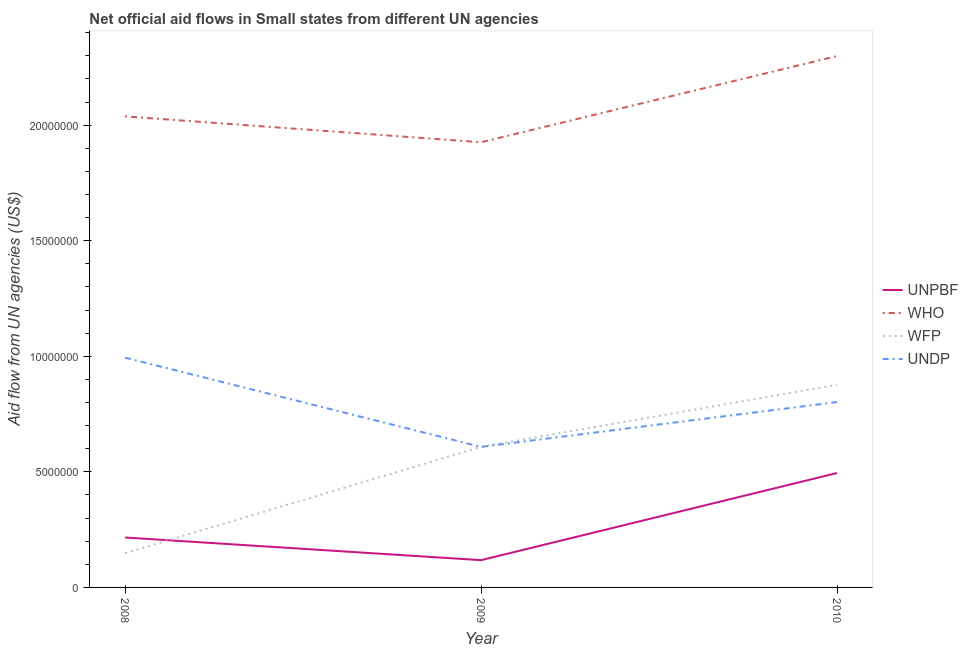Is the number of lines equal to the number of legend labels?
Your response must be concise. Yes. What is the amount of aid given by undp in 2009?
Make the answer very short. 6.08e+06. Across all years, what is the maximum amount of aid given by who?
Keep it short and to the point. 2.30e+07. Across all years, what is the minimum amount of aid given by wfp?
Provide a short and direct response. 1.48e+06. In which year was the amount of aid given by unpbf minimum?
Offer a very short reply. 2009. What is the total amount of aid given by unpbf in the graph?
Ensure brevity in your answer.  8.29e+06. What is the difference between the amount of aid given by wfp in 2009 and that in 2010?
Ensure brevity in your answer.  -2.69e+06. What is the difference between the amount of aid given by who in 2009 and the amount of aid given by undp in 2010?
Ensure brevity in your answer.  1.12e+07. What is the average amount of aid given by undp per year?
Ensure brevity in your answer.  8.01e+06. In the year 2009, what is the difference between the amount of aid given by unpbf and amount of aid given by undp?
Provide a short and direct response. -4.90e+06. What is the ratio of the amount of aid given by unpbf in 2008 to that in 2010?
Ensure brevity in your answer.  0.44. Is the amount of aid given by wfp in 2009 less than that in 2010?
Your answer should be compact. Yes. What is the difference between the highest and the second highest amount of aid given by wfp?
Give a very brief answer. 2.69e+06. What is the difference between the highest and the lowest amount of aid given by undp?
Offer a very short reply. 3.86e+06. Is the amount of aid given by wfp strictly greater than the amount of aid given by unpbf over the years?
Ensure brevity in your answer.  No. How many lines are there?
Provide a short and direct response. 4. How many years are there in the graph?
Your answer should be compact. 3. Are the values on the major ticks of Y-axis written in scientific E-notation?
Provide a short and direct response. No. Does the graph contain grids?
Offer a very short reply. No. Where does the legend appear in the graph?
Your answer should be very brief. Center right. How many legend labels are there?
Offer a very short reply. 4. How are the legend labels stacked?
Offer a terse response. Vertical. What is the title of the graph?
Offer a terse response. Net official aid flows in Small states from different UN agencies. Does "Oil" appear as one of the legend labels in the graph?
Provide a short and direct response. No. What is the label or title of the Y-axis?
Keep it short and to the point. Aid flow from UN agencies (US$). What is the Aid flow from UN agencies (US$) in UNPBF in 2008?
Offer a terse response. 2.16e+06. What is the Aid flow from UN agencies (US$) in WHO in 2008?
Keep it short and to the point. 2.04e+07. What is the Aid flow from UN agencies (US$) in WFP in 2008?
Your answer should be compact. 1.48e+06. What is the Aid flow from UN agencies (US$) of UNDP in 2008?
Offer a terse response. 9.94e+06. What is the Aid flow from UN agencies (US$) in UNPBF in 2009?
Ensure brevity in your answer.  1.18e+06. What is the Aid flow from UN agencies (US$) of WHO in 2009?
Make the answer very short. 1.93e+07. What is the Aid flow from UN agencies (US$) of WFP in 2009?
Give a very brief answer. 6.08e+06. What is the Aid flow from UN agencies (US$) of UNDP in 2009?
Provide a succinct answer. 6.08e+06. What is the Aid flow from UN agencies (US$) of UNPBF in 2010?
Give a very brief answer. 4.95e+06. What is the Aid flow from UN agencies (US$) in WHO in 2010?
Offer a terse response. 2.30e+07. What is the Aid flow from UN agencies (US$) of WFP in 2010?
Your response must be concise. 8.77e+06. What is the Aid flow from UN agencies (US$) of UNDP in 2010?
Offer a very short reply. 8.02e+06. Across all years, what is the maximum Aid flow from UN agencies (US$) of UNPBF?
Your response must be concise. 4.95e+06. Across all years, what is the maximum Aid flow from UN agencies (US$) of WHO?
Offer a terse response. 2.30e+07. Across all years, what is the maximum Aid flow from UN agencies (US$) in WFP?
Your response must be concise. 8.77e+06. Across all years, what is the maximum Aid flow from UN agencies (US$) of UNDP?
Give a very brief answer. 9.94e+06. Across all years, what is the minimum Aid flow from UN agencies (US$) of UNPBF?
Offer a terse response. 1.18e+06. Across all years, what is the minimum Aid flow from UN agencies (US$) of WHO?
Your answer should be very brief. 1.93e+07. Across all years, what is the minimum Aid flow from UN agencies (US$) of WFP?
Ensure brevity in your answer.  1.48e+06. Across all years, what is the minimum Aid flow from UN agencies (US$) in UNDP?
Your answer should be compact. 6.08e+06. What is the total Aid flow from UN agencies (US$) of UNPBF in the graph?
Provide a succinct answer. 8.29e+06. What is the total Aid flow from UN agencies (US$) in WHO in the graph?
Provide a short and direct response. 6.26e+07. What is the total Aid flow from UN agencies (US$) in WFP in the graph?
Your answer should be very brief. 1.63e+07. What is the total Aid flow from UN agencies (US$) of UNDP in the graph?
Offer a terse response. 2.40e+07. What is the difference between the Aid flow from UN agencies (US$) in UNPBF in 2008 and that in 2009?
Give a very brief answer. 9.80e+05. What is the difference between the Aid flow from UN agencies (US$) in WHO in 2008 and that in 2009?
Keep it short and to the point. 1.12e+06. What is the difference between the Aid flow from UN agencies (US$) in WFP in 2008 and that in 2009?
Offer a terse response. -4.60e+06. What is the difference between the Aid flow from UN agencies (US$) of UNDP in 2008 and that in 2009?
Make the answer very short. 3.86e+06. What is the difference between the Aid flow from UN agencies (US$) in UNPBF in 2008 and that in 2010?
Ensure brevity in your answer.  -2.79e+06. What is the difference between the Aid flow from UN agencies (US$) in WHO in 2008 and that in 2010?
Offer a terse response. -2.61e+06. What is the difference between the Aid flow from UN agencies (US$) in WFP in 2008 and that in 2010?
Make the answer very short. -7.29e+06. What is the difference between the Aid flow from UN agencies (US$) of UNDP in 2008 and that in 2010?
Your response must be concise. 1.92e+06. What is the difference between the Aid flow from UN agencies (US$) of UNPBF in 2009 and that in 2010?
Make the answer very short. -3.77e+06. What is the difference between the Aid flow from UN agencies (US$) of WHO in 2009 and that in 2010?
Offer a very short reply. -3.73e+06. What is the difference between the Aid flow from UN agencies (US$) in WFP in 2009 and that in 2010?
Keep it short and to the point. -2.69e+06. What is the difference between the Aid flow from UN agencies (US$) in UNDP in 2009 and that in 2010?
Provide a short and direct response. -1.94e+06. What is the difference between the Aid flow from UN agencies (US$) in UNPBF in 2008 and the Aid flow from UN agencies (US$) in WHO in 2009?
Give a very brief answer. -1.71e+07. What is the difference between the Aid flow from UN agencies (US$) of UNPBF in 2008 and the Aid flow from UN agencies (US$) of WFP in 2009?
Provide a succinct answer. -3.92e+06. What is the difference between the Aid flow from UN agencies (US$) of UNPBF in 2008 and the Aid flow from UN agencies (US$) of UNDP in 2009?
Your response must be concise. -3.92e+06. What is the difference between the Aid flow from UN agencies (US$) of WHO in 2008 and the Aid flow from UN agencies (US$) of WFP in 2009?
Your response must be concise. 1.43e+07. What is the difference between the Aid flow from UN agencies (US$) in WHO in 2008 and the Aid flow from UN agencies (US$) in UNDP in 2009?
Provide a succinct answer. 1.43e+07. What is the difference between the Aid flow from UN agencies (US$) in WFP in 2008 and the Aid flow from UN agencies (US$) in UNDP in 2009?
Your answer should be compact. -4.60e+06. What is the difference between the Aid flow from UN agencies (US$) of UNPBF in 2008 and the Aid flow from UN agencies (US$) of WHO in 2010?
Make the answer very short. -2.08e+07. What is the difference between the Aid flow from UN agencies (US$) in UNPBF in 2008 and the Aid flow from UN agencies (US$) in WFP in 2010?
Provide a short and direct response. -6.61e+06. What is the difference between the Aid flow from UN agencies (US$) in UNPBF in 2008 and the Aid flow from UN agencies (US$) in UNDP in 2010?
Offer a very short reply. -5.86e+06. What is the difference between the Aid flow from UN agencies (US$) in WHO in 2008 and the Aid flow from UN agencies (US$) in WFP in 2010?
Offer a very short reply. 1.16e+07. What is the difference between the Aid flow from UN agencies (US$) in WHO in 2008 and the Aid flow from UN agencies (US$) in UNDP in 2010?
Ensure brevity in your answer.  1.24e+07. What is the difference between the Aid flow from UN agencies (US$) of WFP in 2008 and the Aid flow from UN agencies (US$) of UNDP in 2010?
Give a very brief answer. -6.54e+06. What is the difference between the Aid flow from UN agencies (US$) of UNPBF in 2009 and the Aid flow from UN agencies (US$) of WHO in 2010?
Ensure brevity in your answer.  -2.18e+07. What is the difference between the Aid flow from UN agencies (US$) of UNPBF in 2009 and the Aid flow from UN agencies (US$) of WFP in 2010?
Give a very brief answer. -7.59e+06. What is the difference between the Aid flow from UN agencies (US$) in UNPBF in 2009 and the Aid flow from UN agencies (US$) in UNDP in 2010?
Your answer should be very brief. -6.84e+06. What is the difference between the Aid flow from UN agencies (US$) in WHO in 2009 and the Aid flow from UN agencies (US$) in WFP in 2010?
Provide a short and direct response. 1.05e+07. What is the difference between the Aid flow from UN agencies (US$) of WHO in 2009 and the Aid flow from UN agencies (US$) of UNDP in 2010?
Provide a succinct answer. 1.12e+07. What is the difference between the Aid flow from UN agencies (US$) in WFP in 2009 and the Aid flow from UN agencies (US$) in UNDP in 2010?
Provide a succinct answer. -1.94e+06. What is the average Aid flow from UN agencies (US$) in UNPBF per year?
Offer a very short reply. 2.76e+06. What is the average Aid flow from UN agencies (US$) of WHO per year?
Keep it short and to the point. 2.09e+07. What is the average Aid flow from UN agencies (US$) of WFP per year?
Provide a short and direct response. 5.44e+06. What is the average Aid flow from UN agencies (US$) in UNDP per year?
Make the answer very short. 8.01e+06. In the year 2008, what is the difference between the Aid flow from UN agencies (US$) of UNPBF and Aid flow from UN agencies (US$) of WHO?
Your answer should be compact. -1.82e+07. In the year 2008, what is the difference between the Aid flow from UN agencies (US$) of UNPBF and Aid flow from UN agencies (US$) of WFP?
Your response must be concise. 6.80e+05. In the year 2008, what is the difference between the Aid flow from UN agencies (US$) in UNPBF and Aid flow from UN agencies (US$) in UNDP?
Give a very brief answer. -7.78e+06. In the year 2008, what is the difference between the Aid flow from UN agencies (US$) in WHO and Aid flow from UN agencies (US$) in WFP?
Provide a succinct answer. 1.89e+07. In the year 2008, what is the difference between the Aid flow from UN agencies (US$) of WHO and Aid flow from UN agencies (US$) of UNDP?
Your answer should be very brief. 1.04e+07. In the year 2008, what is the difference between the Aid flow from UN agencies (US$) in WFP and Aid flow from UN agencies (US$) in UNDP?
Your response must be concise. -8.46e+06. In the year 2009, what is the difference between the Aid flow from UN agencies (US$) in UNPBF and Aid flow from UN agencies (US$) in WHO?
Your answer should be compact. -1.81e+07. In the year 2009, what is the difference between the Aid flow from UN agencies (US$) in UNPBF and Aid flow from UN agencies (US$) in WFP?
Give a very brief answer. -4.90e+06. In the year 2009, what is the difference between the Aid flow from UN agencies (US$) in UNPBF and Aid flow from UN agencies (US$) in UNDP?
Ensure brevity in your answer.  -4.90e+06. In the year 2009, what is the difference between the Aid flow from UN agencies (US$) in WHO and Aid flow from UN agencies (US$) in WFP?
Offer a very short reply. 1.32e+07. In the year 2009, what is the difference between the Aid flow from UN agencies (US$) in WHO and Aid flow from UN agencies (US$) in UNDP?
Provide a short and direct response. 1.32e+07. In the year 2010, what is the difference between the Aid flow from UN agencies (US$) in UNPBF and Aid flow from UN agencies (US$) in WHO?
Offer a terse response. -1.80e+07. In the year 2010, what is the difference between the Aid flow from UN agencies (US$) in UNPBF and Aid flow from UN agencies (US$) in WFP?
Provide a short and direct response. -3.82e+06. In the year 2010, what is the difference between the Aid flow from UN agencies (US$) in UNPBF and Aid flow from UN agencies (US$) in UNDP?
Keep it short and to the point. -3.07e+06. In the year 2010, what is the difference between the Aid flow from UN agencies (US$) of WHO and Aid flow from UN agencies (US$) of WFP?
Keep it short and to the point. 1.42e+07. In the year 2010, what is the difference between the Aid flow from UN agencies (US$) in WHO and Aid flow from UN agencies (US$) in UNDP?
Provide a succinct answer. 1.50e+07. In the year 2010, what is the difference between the Aid flow from UN agencies (US$) in WFP and Aid flow from UN agencies (US$) in UNDP?
Make the answer very short. 7.50e+05. What is the ratio of the Aid flow from UN agencies (US$) in UNPBF in 2008 to that in 2009?
Provide a succinct answer. 1.83. What is the ratio of the Aid flow from UN agencies (US$) of WHO in 2008 to that in 2009?
Your answer should be very brief. 1.06. What is the ratio of the Aid flow from UN agencies (US$) in WFP in 2008 to that in 2009?
Provide a succinct answer. 0.24. What is the ratio of the Aid flow from UN agencies (US$) in UNDP in 2008 to that in 2009?
Ensure brevity in your answer.  1.63. What is the ratio of the Aid flow from UN agencies (US$) of UNPBF in 2008 to that in 2010?
Ensure brevity in your answer.  0.44. What is the ratio of the Aid flow from UN agencies (US$) in WHO in 2008 to that in 2010?
Provide a succinct answer. 0.89. What is the ratio of the Aid flow from UN agencies (US$) of WFP in 2008 to that in 2010?
Give a very brief answer. 0.17. What is the ratio of the Aid flow from UN agencies (US$) of UNDP in 2008 to that in 2010?
Provide a short and direct response. 1.24. What is the ratio of the Aid flow from UN agencies (US$) of UNPBF in 2009 to that in 2010?
Give a very brief answer. 0.24. What is the ratio of the Aid flow from UN agencies (US$) in WHO in 2009 to that in 2010?
Keep it short and to the point. 0.84. What is the ratio of the Aid flow from UN agencies (US$) in WFP in 2009 to that in 2010?
Offer a terse response. 0.69. What is the ratio of the Aid flow from UN agencies (US$) of UNDP in 2009 to that in 2010?
Provide a succinct answer. 0.76. What is the difference between the highest and the second highest Aid flow from UN agencies (US$) of UNPBF?
Offer a terse response. 2.79e+06. What is the difference between the highest and the second highest Aid flow from UN agencies (US$) in WHO?
Provide a short and direct response. 2.61e+06. What is the difference between the highest and the second highest Aid flow from UN agencies (US$) of WFP?
Give a very brief answer. 2.69e+06. What is the difference between the highest and the second highest Aid flow from UN agencies (US$) of UNDP?
Offer a terse response. 1.92e+06. What is the difference between the highest and the lowest Aid flow from UN agencies (US$) of UNPBF?
Keep it short and to the point. 3.77e+06. What is the difference between the highest and the lowest Aid flow from UN agencies (US$) in WHO?
Your response must be concise. 3.73e+06. What is the difference between the highest and the lowest Aid flow from UN agencies (US$) in WFP?
Give a very brief answer. 7.29e+06. What is the difference between the highest and the lowest Aid flow from UN agencies (US$) in UNDP?
Offer a very short reply. 3.86e+06. 